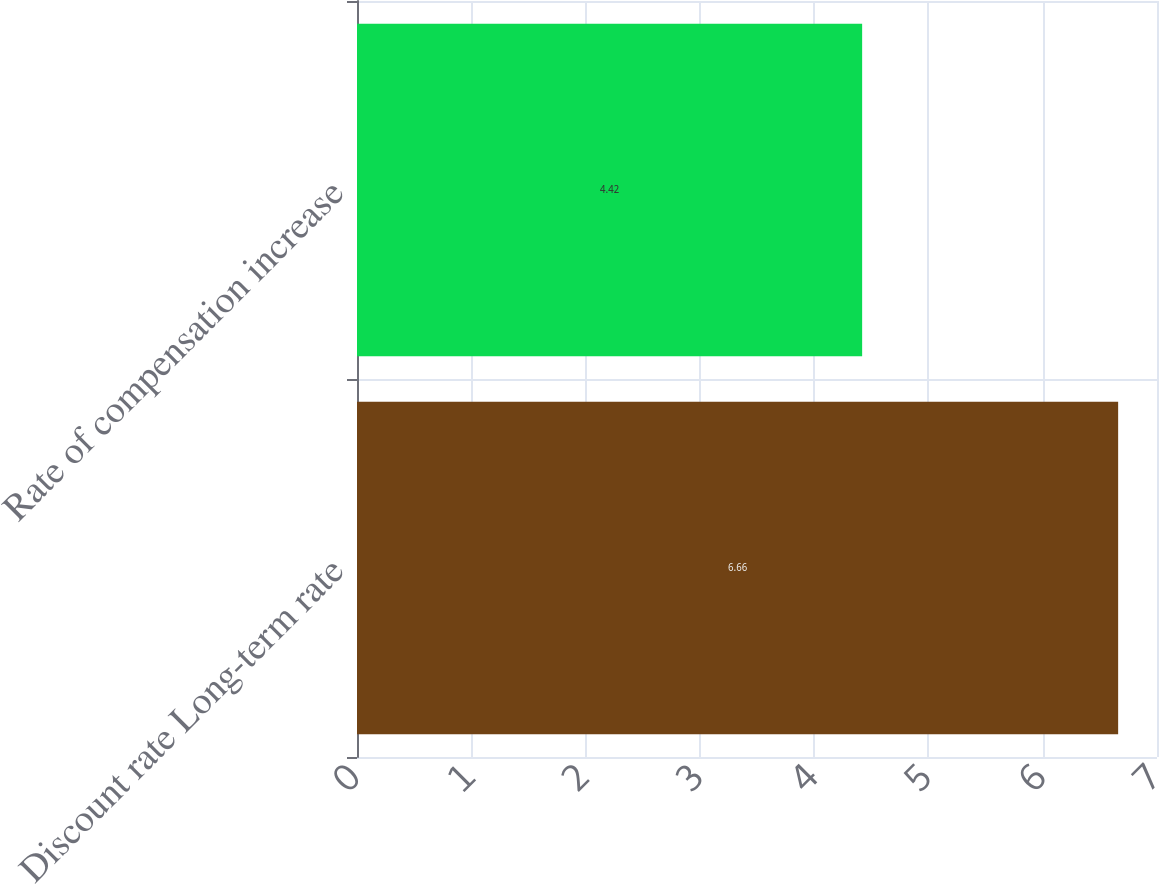Convert chart to OTSL. <chart><loc_0><loc_0><loc_500><loc_500><bar_chart><fcel>Discount rate Long-term rate<fcel>Rate of compensation increase<nl><fcel>6.66<fcel>4.42<nl></chart> 